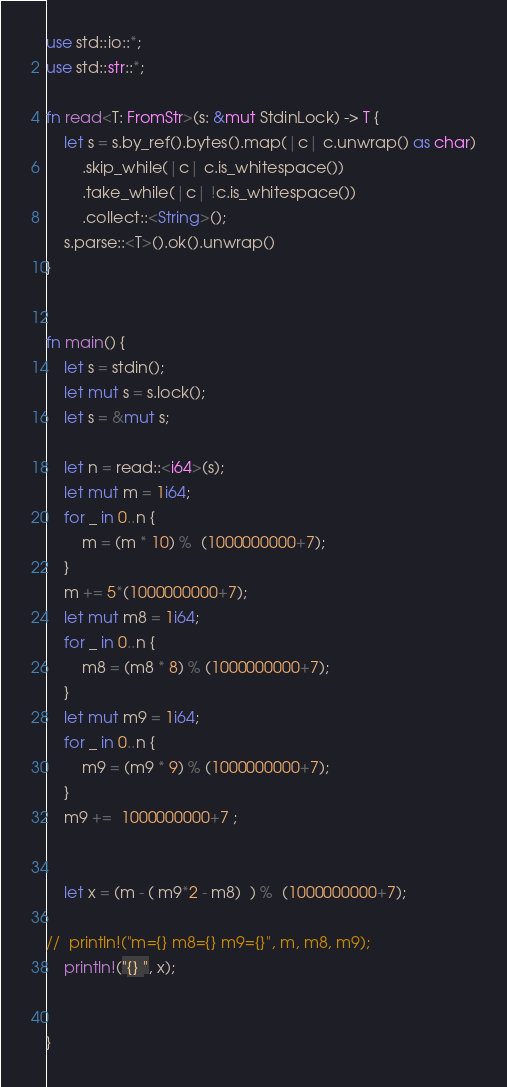<code> <loc_0><loc_0><loc_500><loc_500><_Rust_>use std::io::*;
use std::str::*;

fn read<T: FromStr>(s: &mut StdinLock) -> T {
    let s = s.by_ref().bytes().map(|c| c.unwrap() as char)
        .skip_while(|c| c.is_whitespace())
        .take_while(|c| !c.is_whitespace())
        .collect::<String>();
    s.parse::<T>().ok().unwrap()
}


fn main() {
    let s = stdin();
    let mut s = s.lock();
    let s = &mut s;

	let n = read::<i64>(s);
	let mut m = 1i64;
	for _ in 0..n {
		m = (m * 10) %  (1000000000+7);
	}
	m += 5*(1000000000+7);
	let mut m8 = 1i64;
	for _ in 0..n {
		m8 = (m8 * 8) % (1000000000+7);
	}
	let mut m9 = 1i64;
	for _ in 0..n {
		m9 = (m9 * 9) % (1000000000+7);
	}
	m9 +=  1000000000+7 ;	
	

	let x = (m - ( m9*2 - m8)  ) %  (1000000000+7);

//	println!("m={} m8={} m9={}", m, m8, m9);
	println!("{} ", x);


}

</code> 